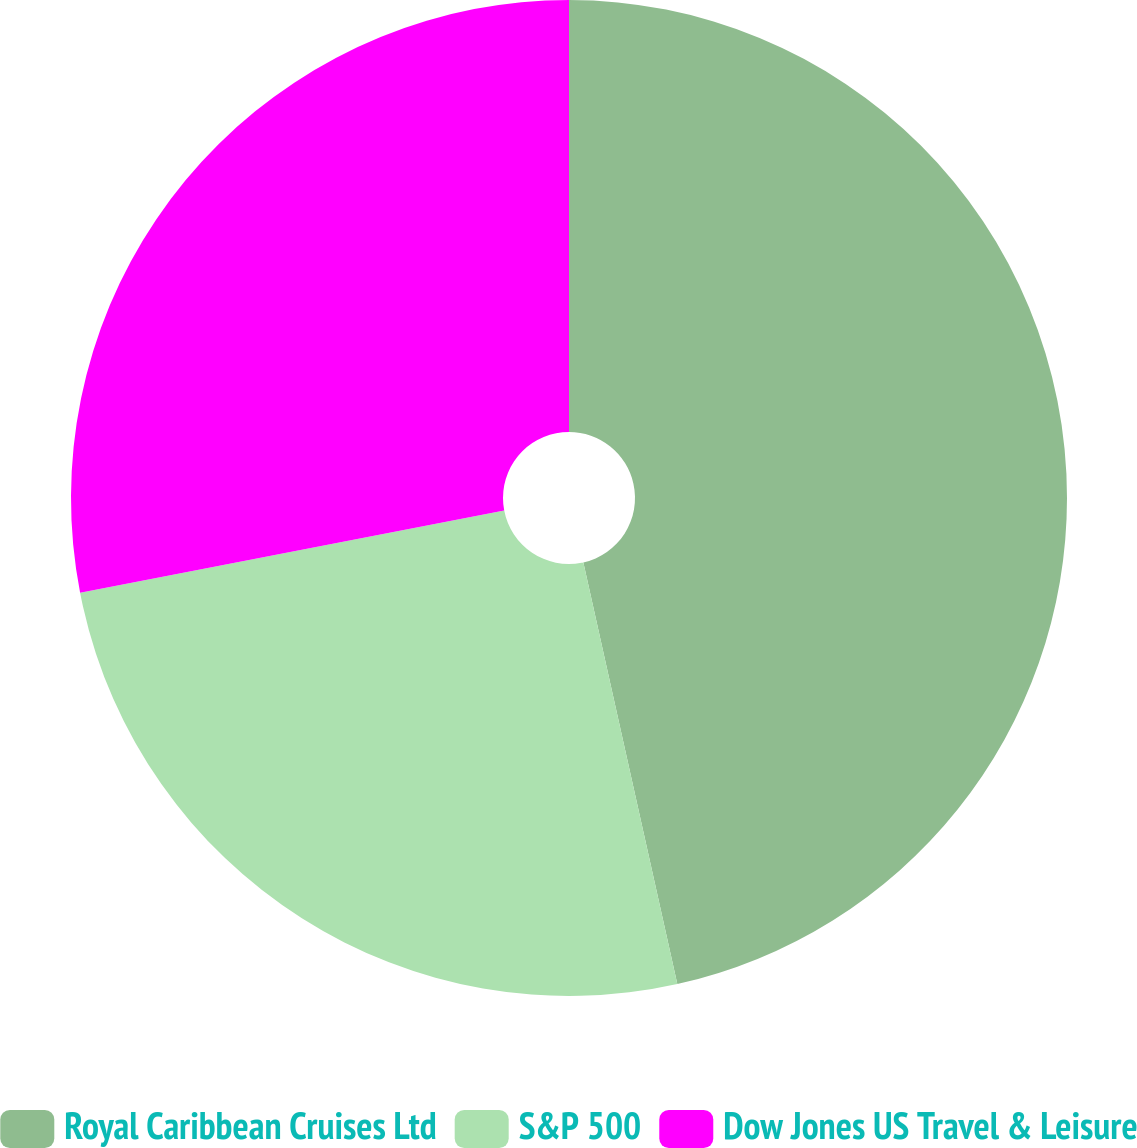Convert chart. <chart><loc_0><loc_0><loc_500><loc_500><pie_chart><fcel>Royal Caribbean Cruises Ltd<fcel>S&P 500<fcel>Dow Jones US Travel & Leisure<nl><fcel>46.51%<fcel>25.44%<fcel>28.05%<nl></chart> 